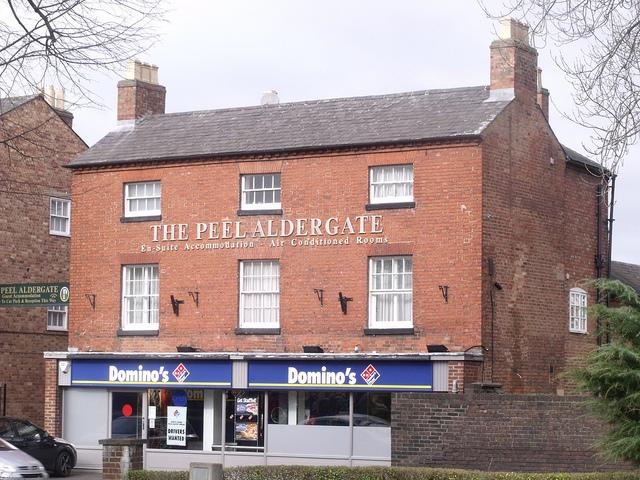What pizza place is on the main level? domino's 